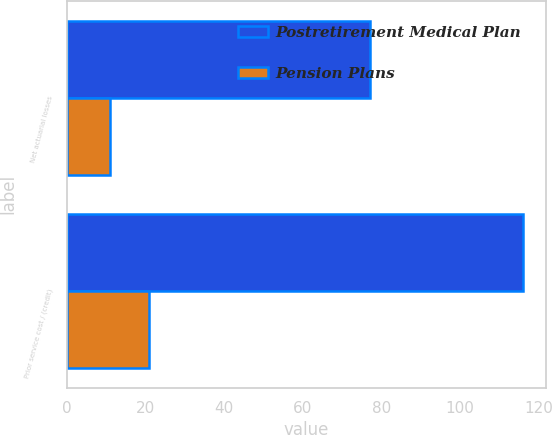<chart> <loc_0><loc_0><loc_500><loc_500><stacked_bar_chart><ecel><fcel>Net actuarial losses<fcel>Prior service cost / (credit)<nl><fcel>Postretirement Medical Plan<fcel>77<fcel>116<nl><fcel>Pension Plans<fcel>11<fcel>21<nl></chart> 